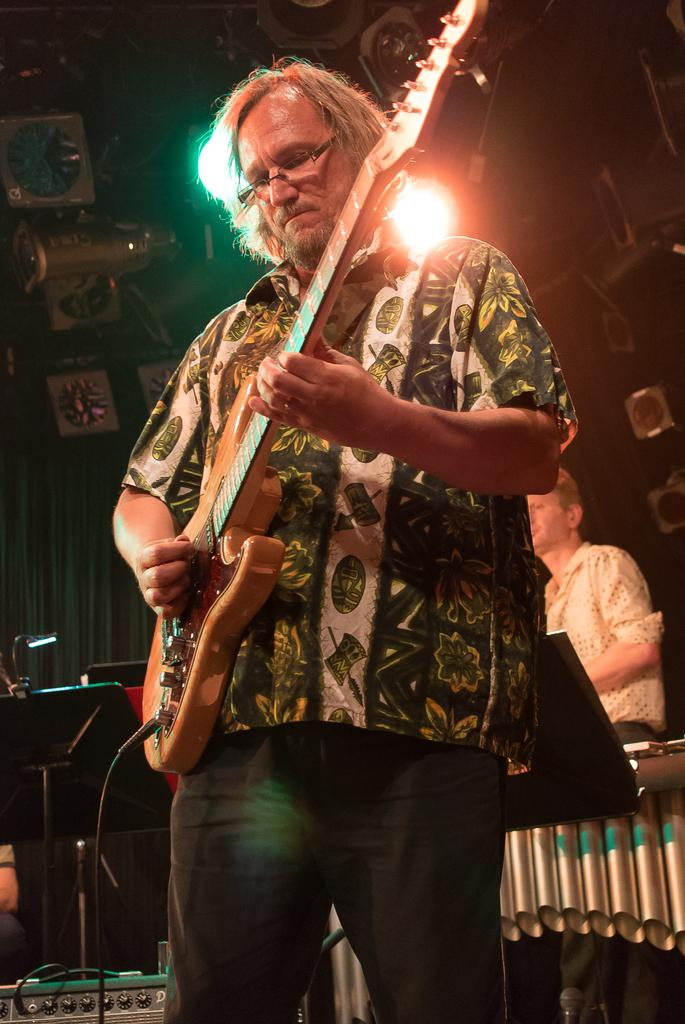What is the man in the image holding? The man is holding a guitar. What is the man's posture in the image? The man is standing. Can you describe the background of the image? There are 2 lights and a person in the background of the image. Can you tell me the name of the giraffe in the image? There is no giraffe present in the image. What type of sidewalk can be seen in the image? There is no sidewalk visible in the image. 